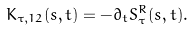Convert formula to latex. <formula><loc_0><loc_0><loc_500><loc_500>K _ { \tau , 1 2 } ( s , t ) = - \partial _ { t } S ^ { R } _ { \tau } ( s , t ) .</formula> 